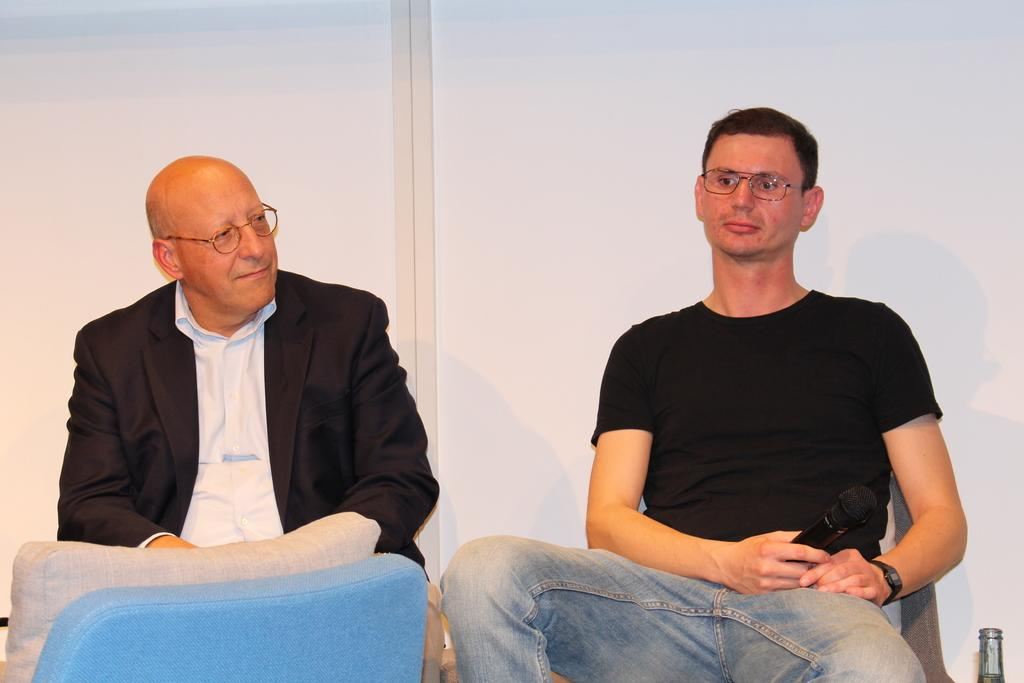How many people are in the image? There are persons in the image, but the exact number cannot be determined from the provided facts. What object is present that is typically used for amplifying sound? There is a microphone in the image. What other objects can be seen in the image besides the microphone? There are other objects in the image, but their specific nature cannot be determined from the provided facts. What can be seen in the background of the image? There is a wall visible in the background of the image. Can you tell me how many chains are being balanced by the persons in the image? There is no mention of chains or balancing in the provided facts, so it cannot be determined from the image. 